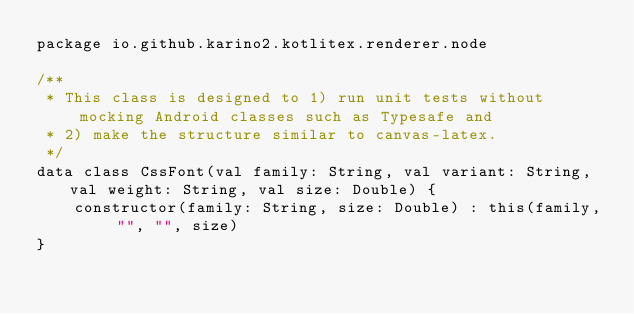<code> <loc_0><loc_0><loc_500><loc_500><_Kotlin_>package io.github.karino2.kotlitex.renderer.node

/**
 * This class is designed to 1) run unit tests without mocking Android classes such as Typesafe and
 * 2) make the structure similar to canvas-latex.
 */
data class CssFont(val family: String, val variant: String, val weight: String, val size: Double) {
    constructor(family: String, size: Double) : this(family, "", "", size)
}</code> 